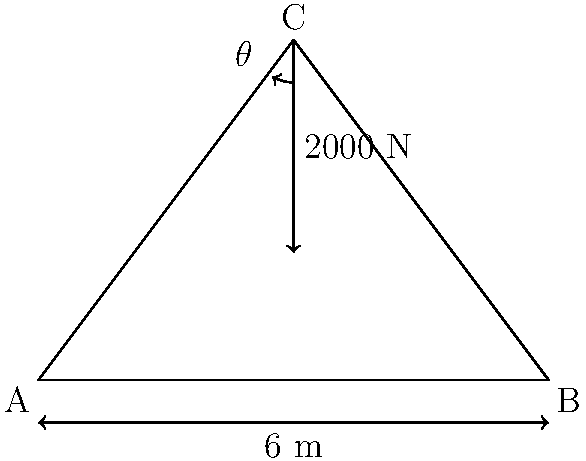A simple truss structure ABC is shown in the figure. A vertical force of 2000 N is applied at point C. The truss is symmetrical, and the angle between AC and BC is $\theta$. If the height of the truss is 4 m and the base is 6 m wide, calculate the magnitude of the force in member AC of the truss. To solve this problem, we'll follow these steps:

1) First, we need to find the angle $\theta$. We can do this using the tangent function:

   $$\tan \theta = \frac{\text{opposite}}{\text{adjacent}} = \frac{4}{3} = 1.333$$

   $$\theta = \arctan(1.333) = 53.13^\circ$$

2) Now, we can use the method of joints to analyze the forces at point C. Since the truss is symmetrical, the forces in AC and BC will be equal. Let's call this force F.

3) At point C, we have three forces in equilibrium: the 2000 N downward force and the two equal forces F in the AC and BC members.

4) We can resolve the forces in the vertical direction:

   $$2F \sin \theta = 2000 \text{ N}$$

5) Solving for F:

   $$F = \frac{2000 \text{ N}}{2 \sin \theta} = \frac{2000 \text{ N}}{2 \sin 53.13^\circ}$$

6) Calculate the final result:

   $$F = \frac{2000 \text{ N}}{2 * 0.8} = 1250 \text{ N}$$

Therefore, the magnitude of the force in member AC is 1250 N.
Answer: 1250 N 